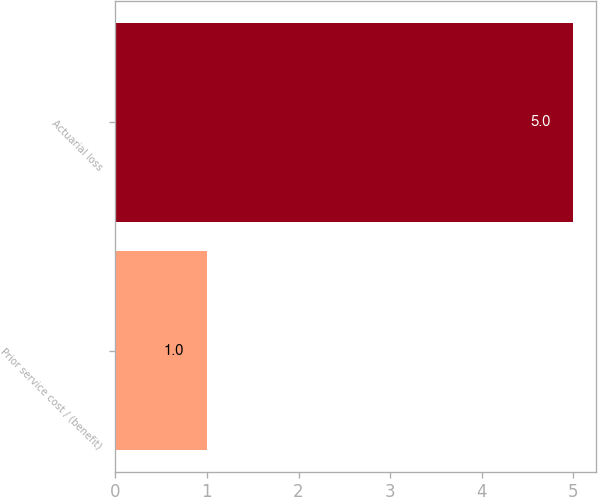<chart> <loc_0><loc_0><loc_500><loc_500><bar_chart><fcel>Prior service cost / (benefit)<fcel>Actuarial loss<nl><fcel>1<fcel>5<nl></chart> 